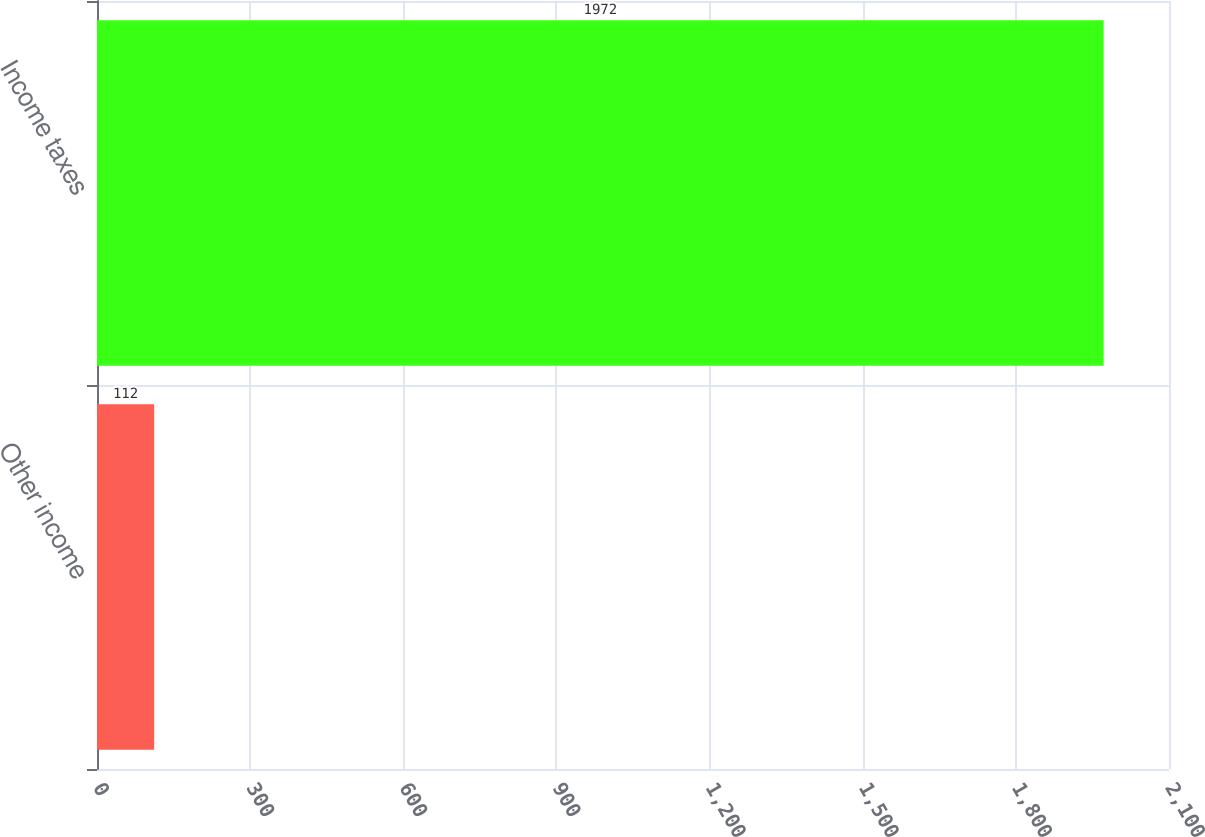Convert chart to OTSL. <chart><loc_0><loc_0><loc_500><loc_500><bar_chart><fcel>Other income<fcel>Income taxes<nl><fcel>112<fcel>1972<nl></chart> 